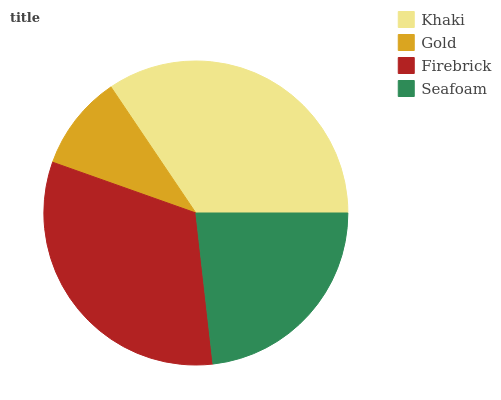Is Gold the minimum?
Answer yes or no. Yes. Is Khaki the maximum?
Answer yes or no. Yes. Is Firebrick the minimum?
Answer yes or no. No. Is Firebrick the maximum?
Answer yes or no. No. Is Firebrick greater than Gold?
Answer yes or no. Yes. Is Gold less than Firebrick?
Answer yes or no. Yes. Is Gold greater than Firebrick?
Answer yes or no. No. Is Firebrick less than Gold?
Answer yes or no. No. Is Firebrick the high median?
Answer yes or no. Yes. Is Seafoam the low median?
Answer yes or no. Yes. Is Khaki the high median?
Answer yes or no. No. Is Firebrick the low median?
Answer yes or no. No. 